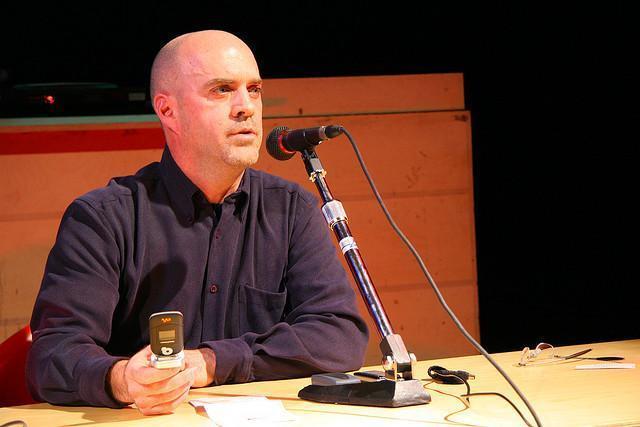How many orange fruit are there?
Give a very brief answer. 0. 